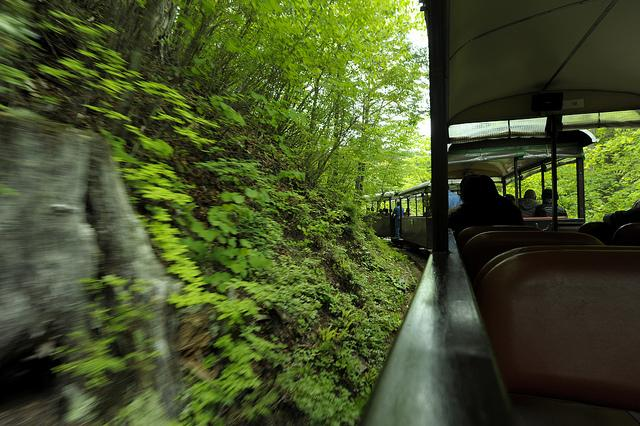If you stuck your hand out the side what would happen?

Choices:
A) get electrocuted
B) touch people
C) touch cats
D) touch plants touch plants 